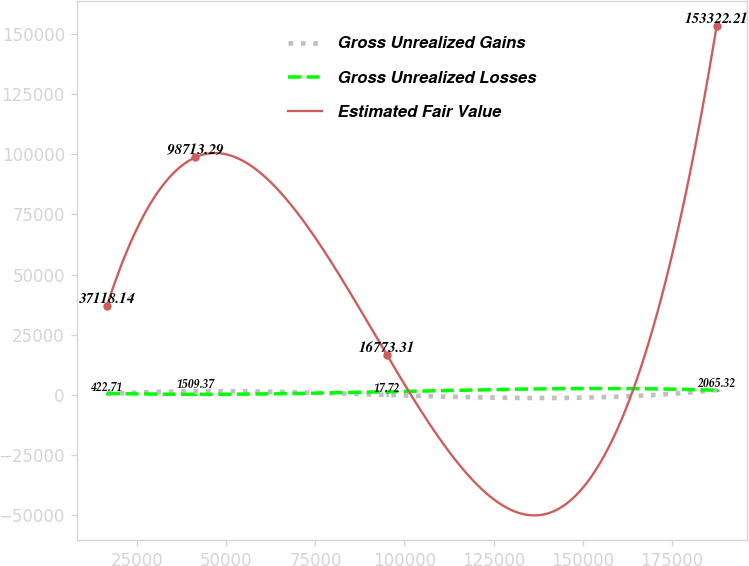Convert chart to OTSL. <chart><loc_0><loc_0><loc_500><loc_500><line_chart><ecel><fcel>Gross Unrealized Gains<fcel>Gross Unrealized Losses<fcel>Estimated Fair Value<nl><fcel>16479.9<fcel>422.71<fcel>696.49<fcel>37118.1<nl><fcel>41281.8<fcel>1509.37<fcel>254.75<fcel>98713.3<nl><fcel>94993.2<fcel>17.72<fcel>1345.72<fcel>16773.3<nl><fcel>187638<fcel>2065.32<fcel>1948.93<fcel>153322<nl></chart> 